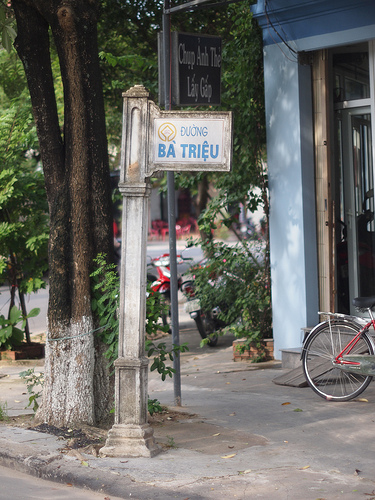Please provide the bounding box coordinate of the region this sentence describes: leaves on the tree. The coordinates for the bounding box around the region described as 'leaves on the tree' are approximately [0.43, 0.71, 0.47, 0.76]. 